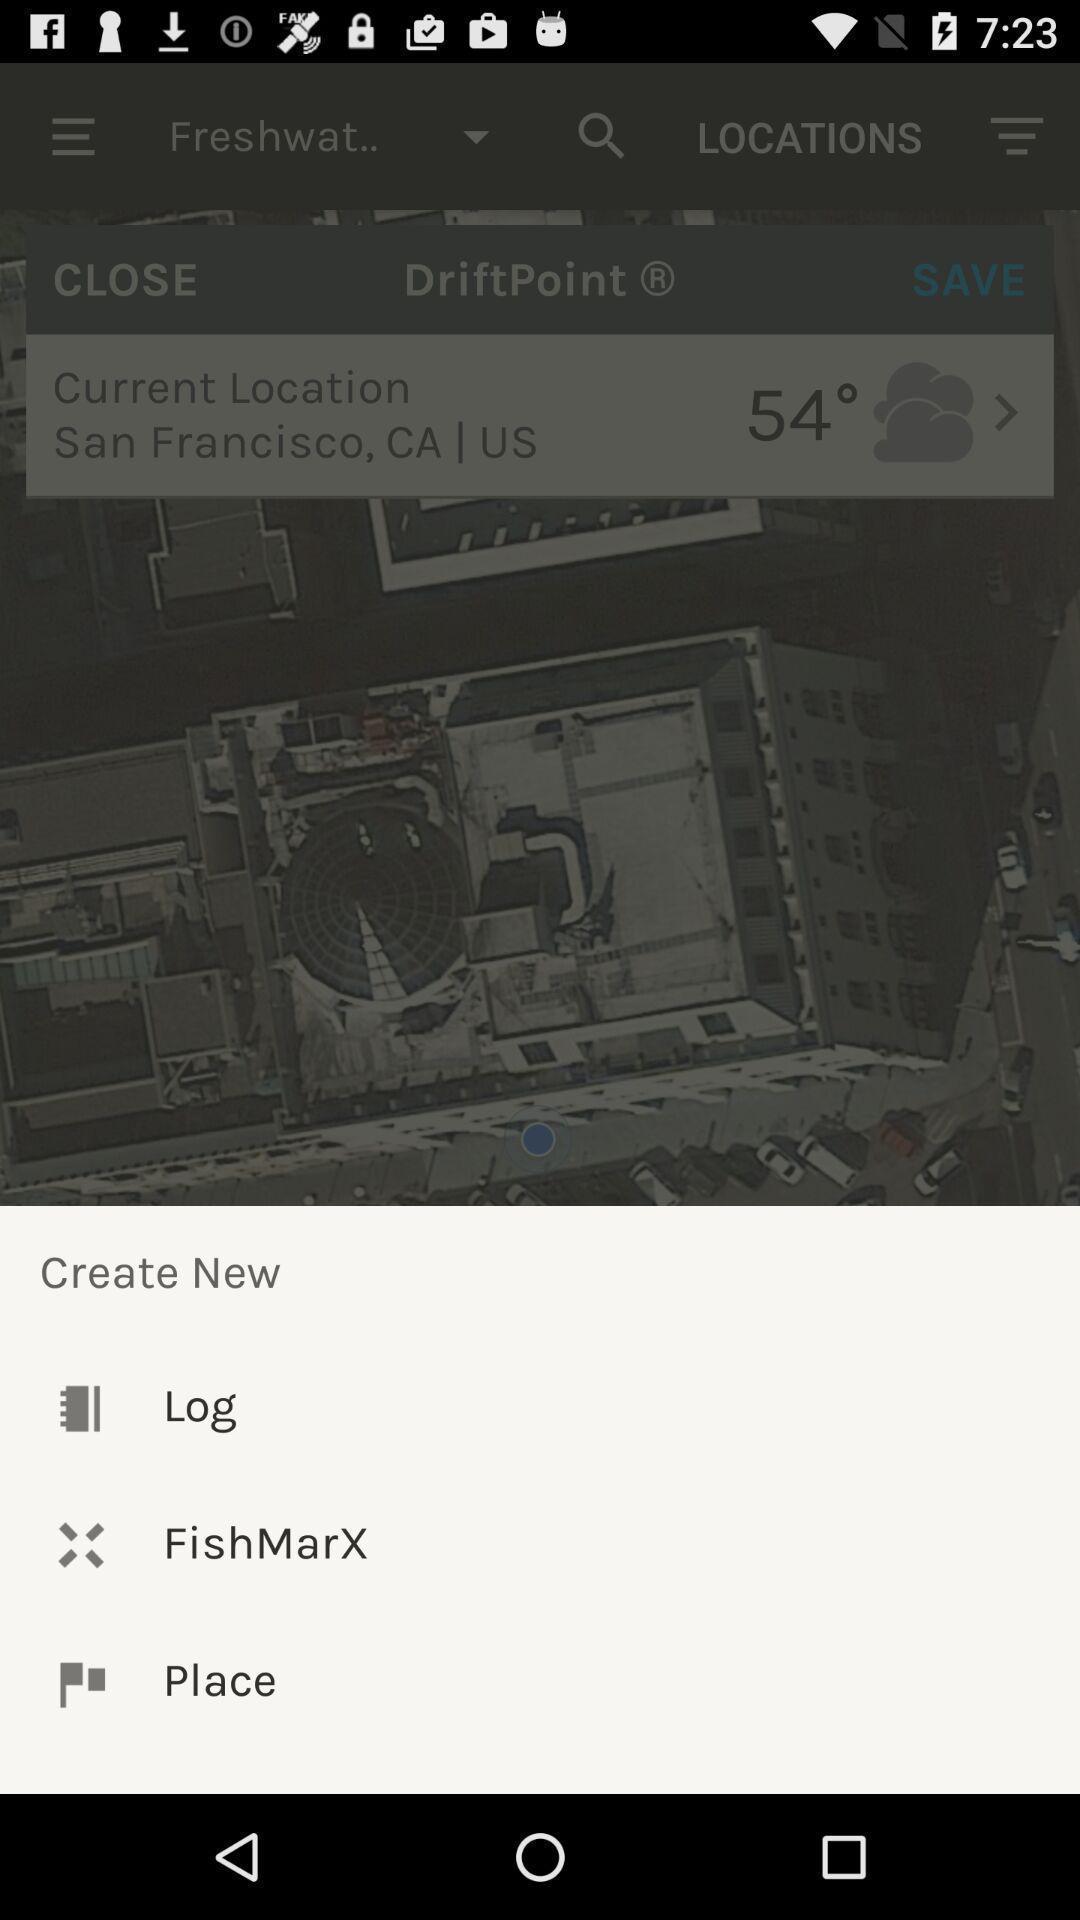Explain what's happening in this screen capture. Pop up with list of options on app. 